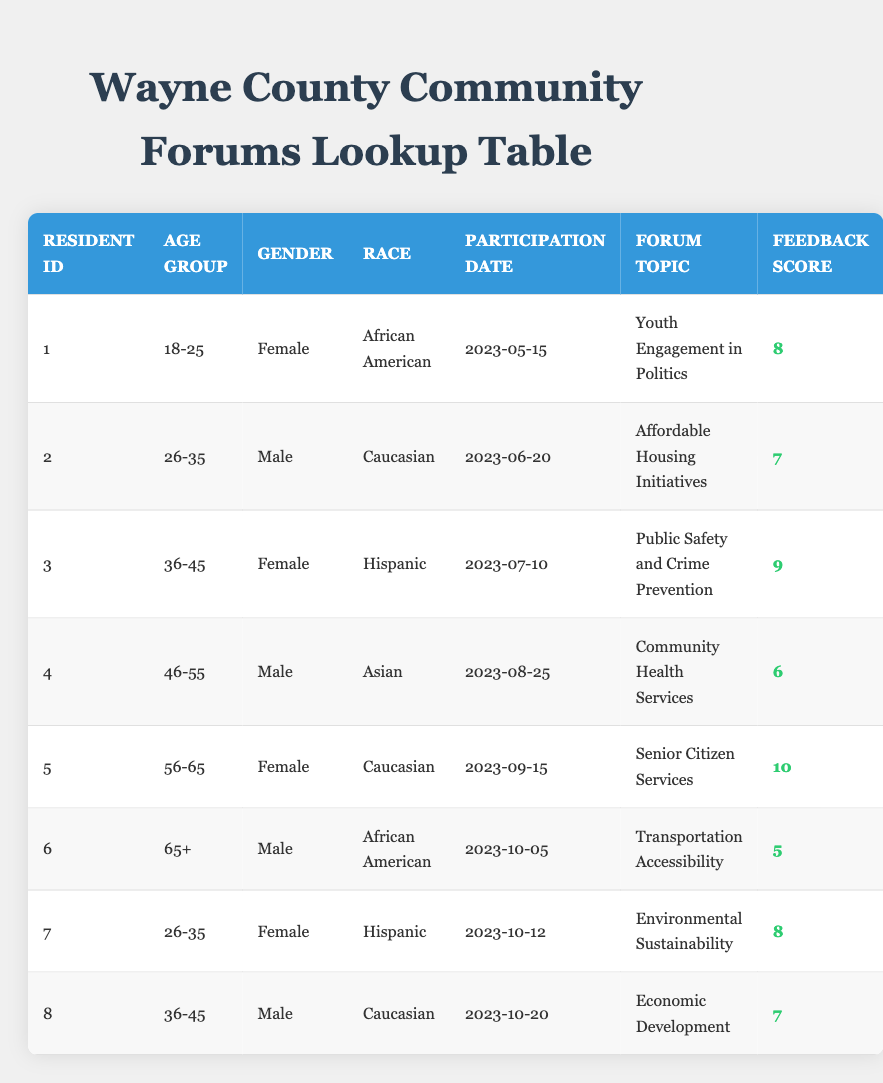What is the forum topic of resident ID 5? According to the table, resident ID 5 participated in the forum topic "Senior Citizen Services."
Answer: Senior Citizen Services How many residents participated in the community forums aged 36-45? There are two residents (IDs 3 and 8) who belong to the 36-45 age group.
Answer: 2 What was the participation date of the resident who provided the highest feedback score? Resident ID 5 provided the highest feedback score of 10 on the participation date of 2023-09-15.
Answer: 2023-09-15 Is there a male resident who participated in a forum on "Affordable Housing Initiatives"? No, the only resident who participated in that forum (resident ID 2) is male, but he did not participate in a separate forum on "Affordable Housing Initiatives."
Answer: Yes What is the average feedback score of female residents? The feedback scores for female residents (IDs 1, 3, 5, and 7) are 8, 9, 10, and 8, respectively. The sum is 8 + 9 + 10 + 8 = 35, and there are 4 female residents, so the average score is 35/4 = 8.75.
Answer: 8.75 Which race has the highest feedback score based on this data? The feedback scores are: African American (8, 5), Caucasian (7, 10, 7), Hispanic (9, 8), and Asian (6). The maximum score is 10, which belongs to Caucasian residents (ID 5).
Answer: Caucasian What percentage of the participants are from the age group 65 and older? There is 1 resident aged 65+, and there are a total of 8 participants. The percentage is (1/8) * 100 = 12.5%.
Answer: 12.5% What forum topic did the male resident aged 46-55 participate in? The male resident aged 46-55 (ID 4) participated in the forum topic "Community Health Services."
Answer: Community Health Services Was there any resident who provided a feedback score of 6 or lower? Yes, both male resident ID 4 (score of 6) and male resident ID 6 (score of 5) provided scores of 6 or lower.
Answer: Yes 